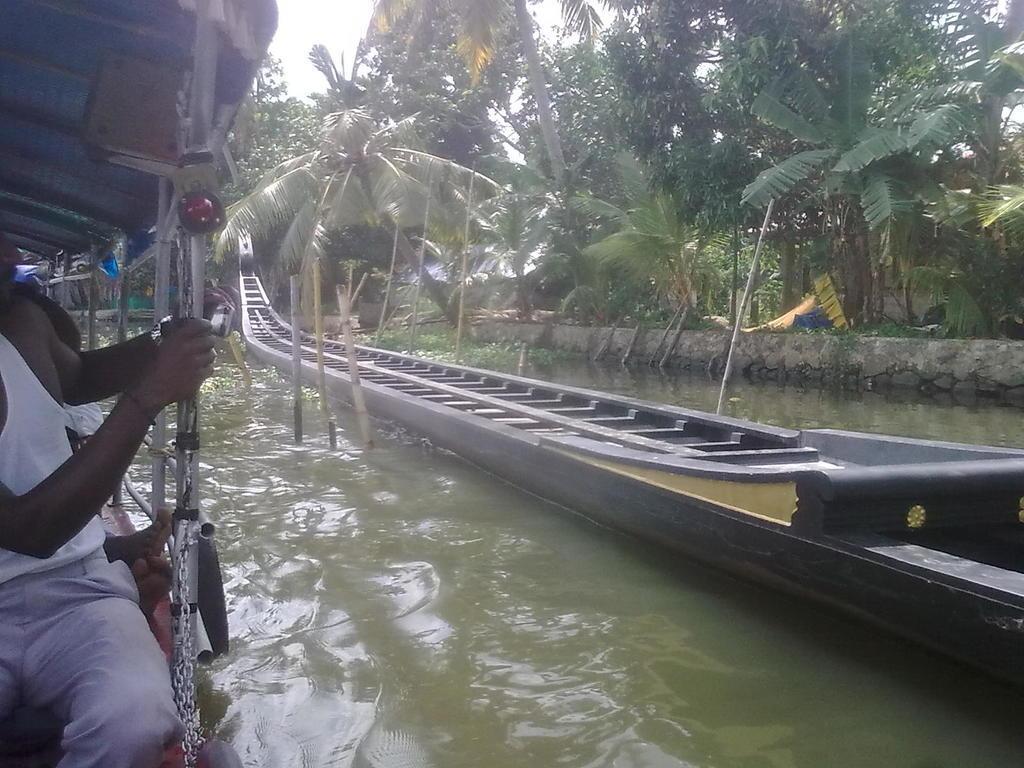Could you give a brief overview of what you see in this image? In this image we can see a boat in the water, here a person is sitting, here are the trees, at above here is the sky. 